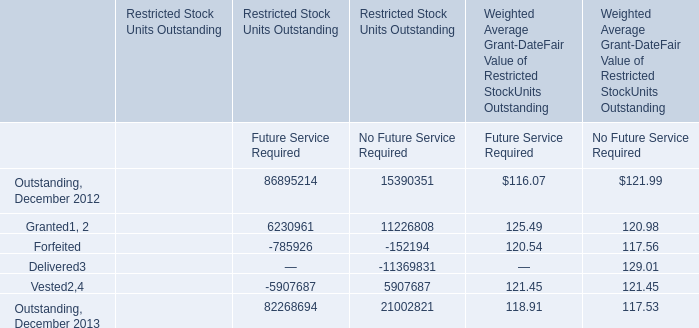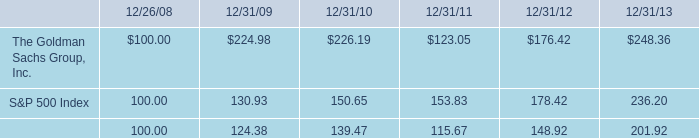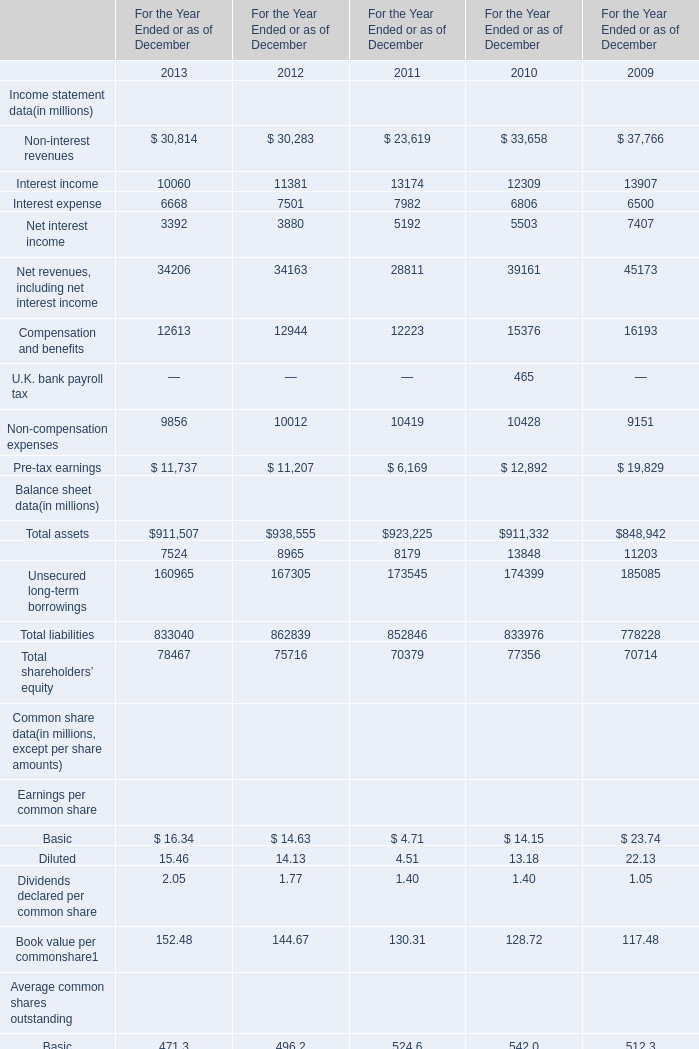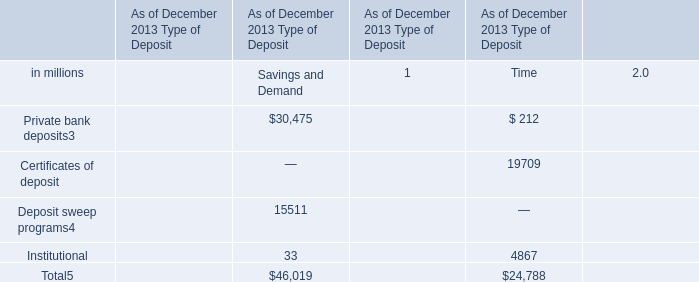If Net interest income develops with the same growth rate in 2011, what will it reach in 2013? (in million) 
Computations: ((5192 * (1 + ((5192 - 5503) / 5503))) * (1 + ((5192 - 5503) / 5503)))
Answer: 4621.73484. 